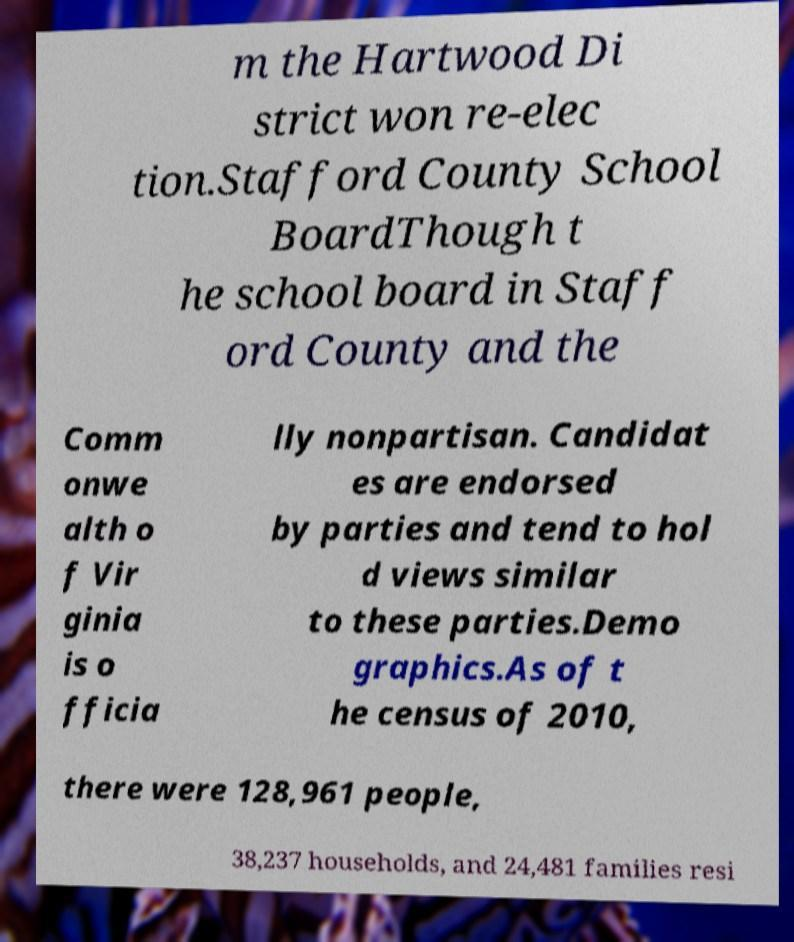Could you extract and type out the text from this image? m the Hartwood Di strict won re-elec tion.Stafford County School BoardThough t he school board in Staff ord County and the Comm onwe alth o f Vir ginia is o fficia lly nonpartisan. Candidat es are endorsed by parties and tend to hol d views similar to these parties.Demo graphics.As of t he census of 2010, there were 128,961 people, 38,237 households, and 24,481 families resi 